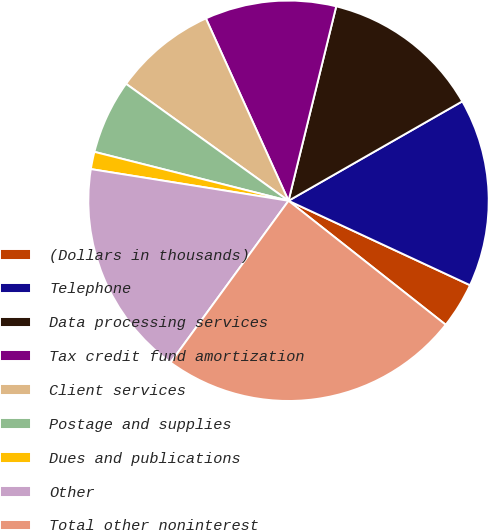Convert chart. <chart><loc_0><loc_0><loc_500><loc_500><pie_chart><fcel>(Dollars in thousands)<fcel>Telephone<fcel>Data processing services<fcel>Tax credit fund amortization<fcel>Client services<fcel>Postage and supplies<fcel>Dues and publications<fcel>Other<fcel>Total other noninterest<nl><fcel>3.7%<fcel>15.2%<fcel>12.9%<fcel>10.6%<fcel>8.3%<fcel>6.0%<fcel>1.4%<fcel>17.5%<fcel>24.4%<nl></chart> 